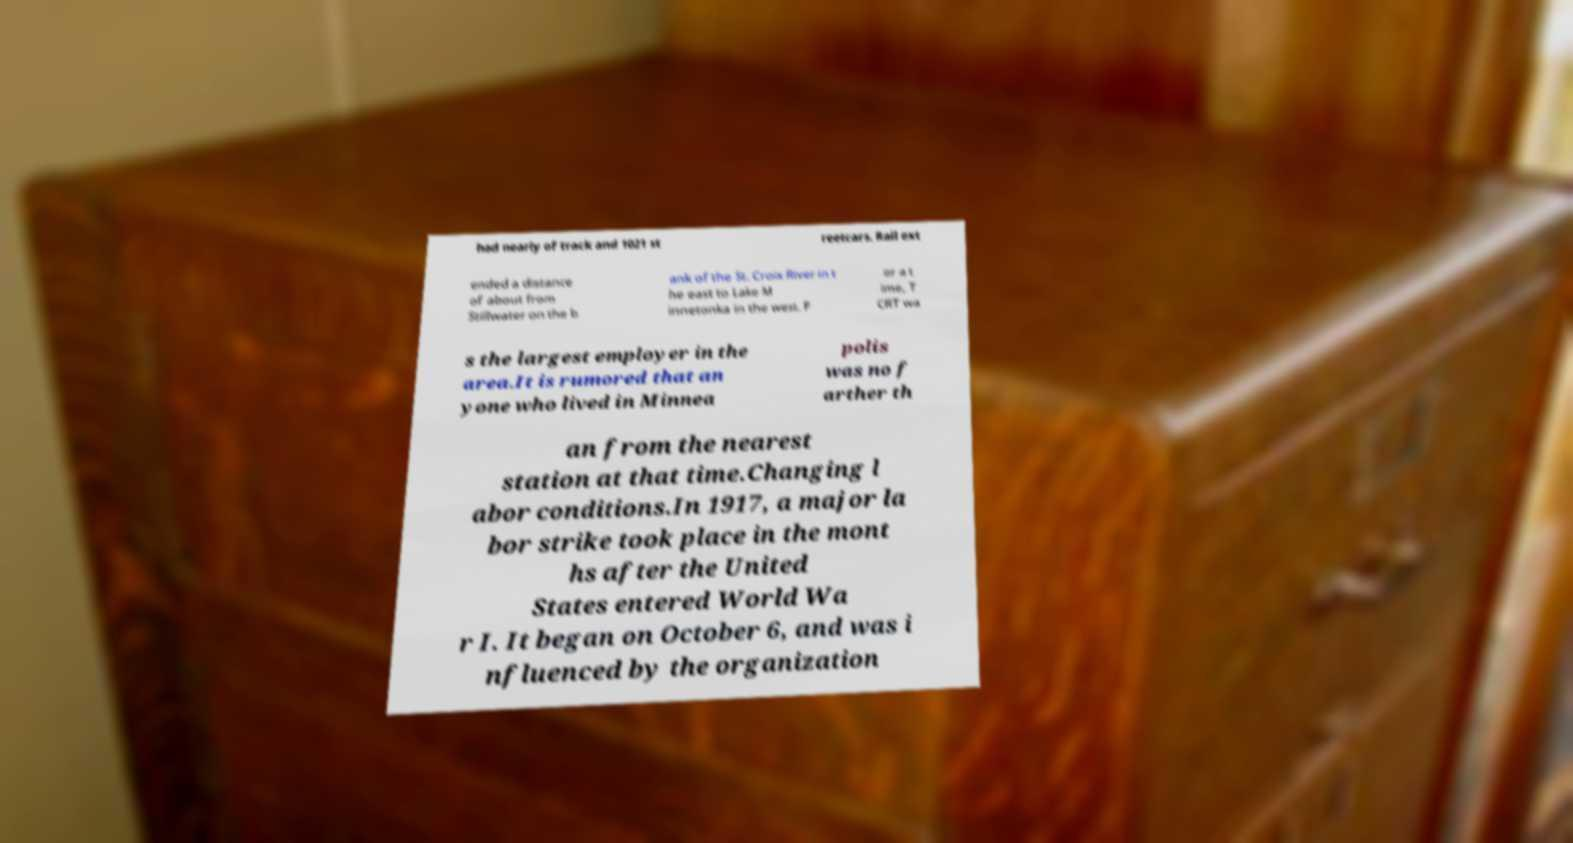Please read and relay the text visible in this image. What does it say? had nearly of track and 1021 st reetcars. Rail ext ended a distance of about from Stillwater on the b ank of the St. Croix River in t he east to Lake M innetonka in the west. F or a t ime, T CRT wa s the largest employer in the area.It is rumored that an yone who lived in Minnea polis was no f arther th an from the nearest station at that time.Changing l abor conditions.In 1917, a major la bor strike took place in the mont hs after the United States entered World Wa r I. It began on October 6, and was i nfluenced by the organization 